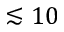<formula> <loc_0><loc_0><loc_500><loc_500>\lesssim 1 0</formula> 